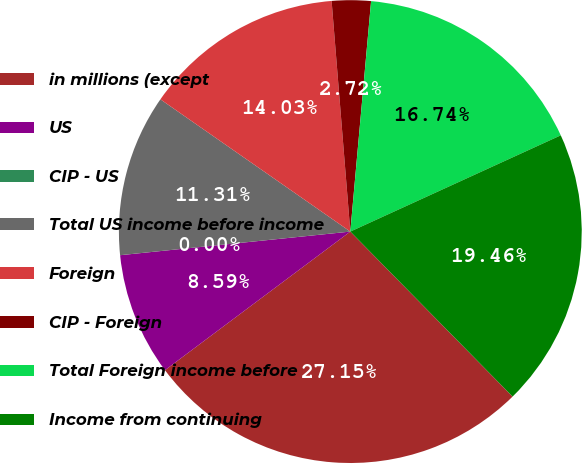Convert chart to OTSL. <chart><loc_0><loc_0><loc_500><loc_500><pie_chart><fcel>in millions (except<fcel>US<fcel>CIP - US<fcel>Total US income before income<fcel>Foreign<fcel>CIP - Foreign<fcel>Total Foreign income before<fcel>Income from continuing<nl><fcel>27.15%<fcel>8.59%<fcel>0.0%<fcel>11.31%<fcel>14.03%<fcel>2.72%<fcel>16.74%<fcel>19.46%<nl></chart> 